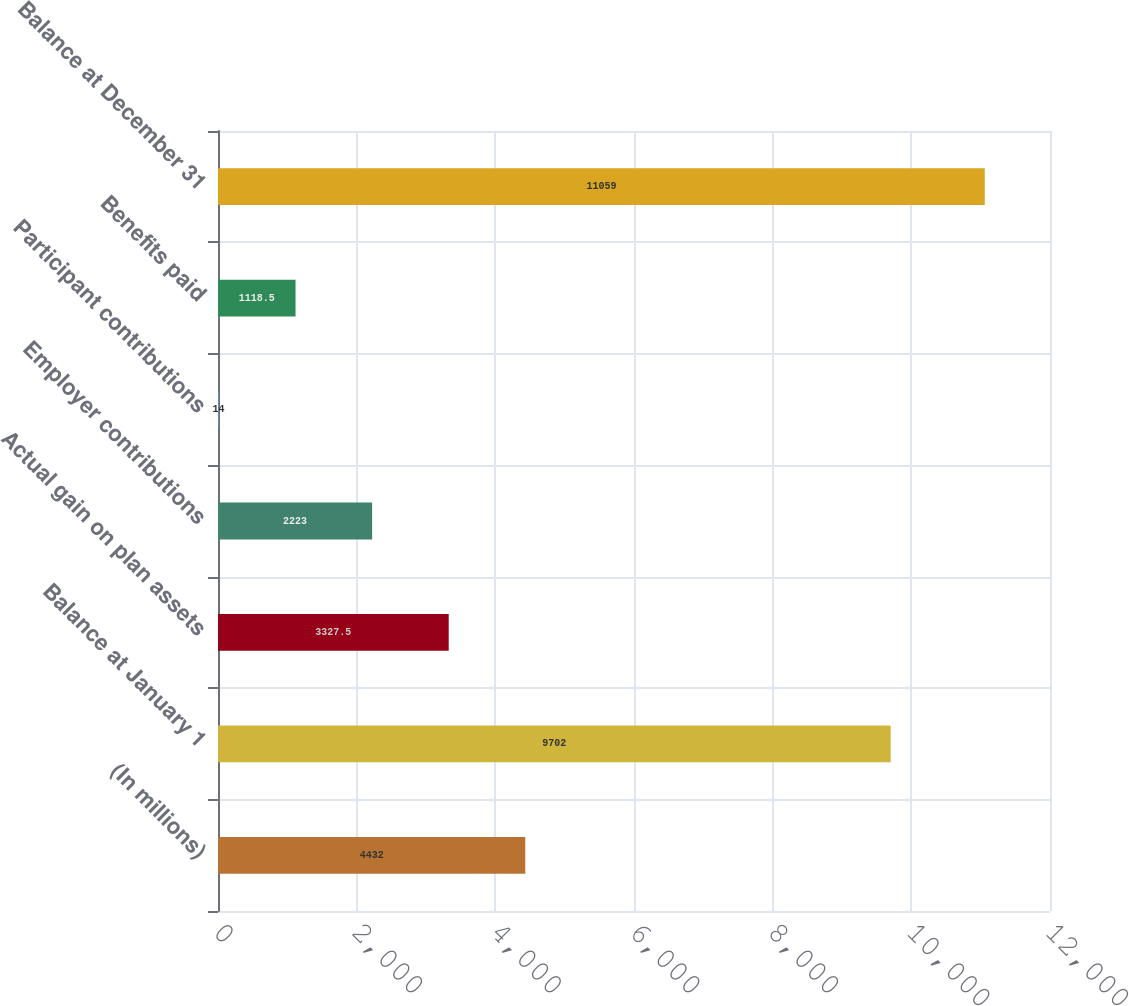Convert chart. <chart><loc_0><loc_0><loc_500><loc_500><bar_chart><fcel>(In millions)<fcel>Balance at January 1<fcel>Actual gain on plan assets<fcel>Employer contributions<fcel>Participant contributions<fcel>Benefits paid<fcel>Balance at December 31<nl><fcel>4432<fcel>9702<fcel>3327.5<fcel>2223<fcel>14<fcel>1118.5<fcel>11059<nl></chart> 